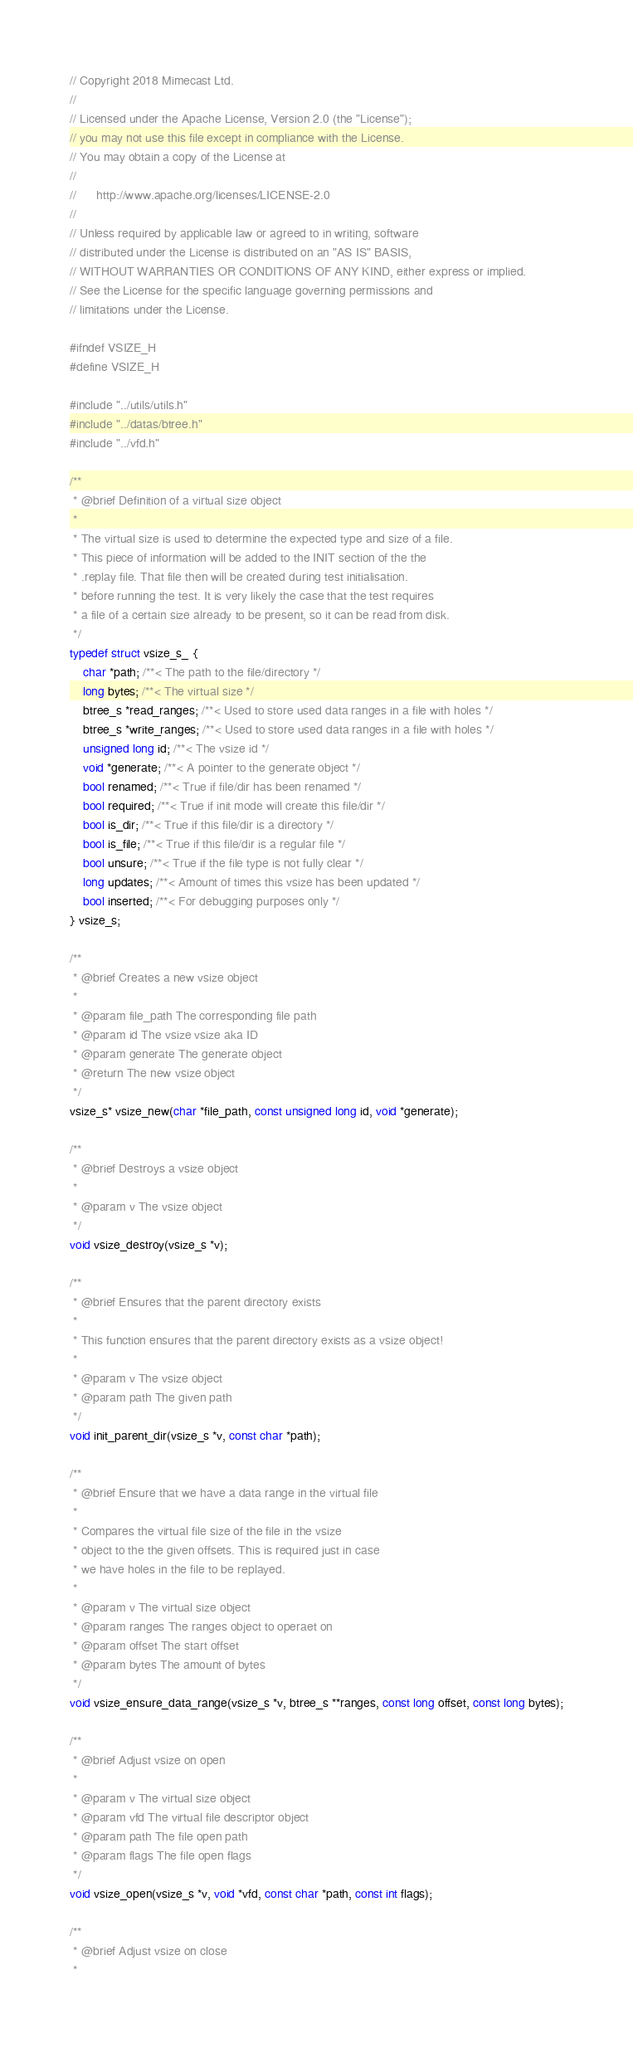<code> <loc_0><loc_0><loc_500><loc_500><_C_>// Copyright 2018 Mimecast Ltd.
//
// Licensed under the Apache License, Version 2.0 (the "License");
// you may not use this file except in compliance with the License.
// You may obtain a copy of the License at
//
//      http://www.apache.org/licenses/LICENSE-2.0
//
// Unless required by applicable law or agreed to in writing, software
// distributed under the License is distributed on an "AS IS" BASIS,
// WITHOUT WARRANTIES OR CONDITIONS OF ANY KIND, either express or implied.
// See the License for the specific language governing permissions and
// limitations under the License.

#ifndef VSIZE_H
#define VSIZE_H

#include "../utils/utils.h"
#include "../datas/btree.h"
#include "../vfd.h"

/**
 * @brief Definition of a virtual size object
 *
 * The virtual size is used to determine the expected type and size of a file.
 * This piece of information will be added to the INIT section of the the
 * .replay file. That file then will be created during test initialisation.
 * before running the test. It is very likely the case that the test requires
 * a file of a certain size already to be present, so it can be read from disk.
 */
typedef struct vsize_s_ {
    char *path; /**< The path to the file/directory */
    long bytes; /**< The virtual size */
    btree_s *read_ranges; /**< Used to store used data ranges in a file with holes */
    btree_s *write_ranges; /**< Used to store used data ranges in a file with holes */
    unsigned long id; /**< The vsize id */
    void *generate; /**< A pointer to the generate object */
    bool renamed; /**< True if file/dir has been renamed */
    bool required; /**< True if init mode will create this file/dir */
    bool is_dir; /**< True if this file/dir is a directory */
    bool is_file; /**< True if this file/dir is a regular file */
    bool unsure; /**< True if the file type is not fully clear */
    long updates; /**< Amount of times this vsize has been updated */
    bool inserted; /**< For debugging purposes only */
} vsize_s;

/**
 * @brief Creates a new vsize object
 *
 * @param file_path The corresponding file path
 * @param id The vsize vsize aka ID
 * @param generate The generate object
 * @return The new vsize object
 */
vsize_s* vsize_new(char *file_path, const unsigned long id, void *generate);

/**
 * @brief Destroys a vsize object
 *
 * @param v The vsize object
 */
void vsize_destroy(vsize_s *v);

/**
 * @brief Ensures that the parent directory exists
 *
 * This function ensures that the parent directory exists as a vsize object!
 *
 * @param v The vsize object
 * @param path The given path
 */
void init_parent_dir(vsize_s *v, const char *path);

/**
 * @brief Ensure that we have a data range in the virtual file
 *
 * Compares the virtual file size of the file in the vsize
 * object to the the given offsets. This is required just in case
 * we have holes in the file to be replayed.
 *
 * @param v The virtual size object
 * @param ranges The ranges object to operaet on
 * @param offset The start offset
 * @param bytes The amount of bytes
 */
void vsize_ensure_data_range(vsize_s *v, btree_s **ranges, const long offset, const long bytes);

/**
 * @brief Adjust vsize on open
 *
 * @param v The virtual size object
 * @param vfd The virtual file descriptor object
 * @param path The file open path
 * @param flags The file open flags
 */
void vsize_open(vsize_s *v, void *vfd, const char *path, const int flags);

/**
 * @brief Adjust vsize on close
 *</code> 